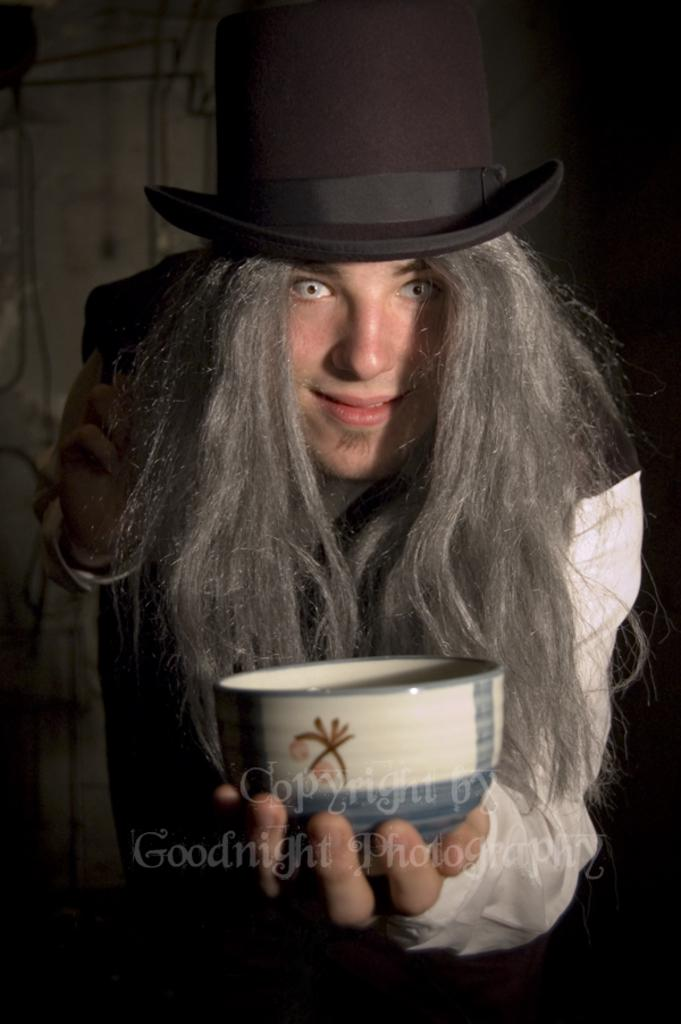What is the main subject of the image? There is a person in the image. What is the person wearing? The person is wearing a hat. What is the person holding? The person is holding a bowl. How would you describe the background of the image? The background of the image is dark. What stage of the key-making process is depicted in the image? There is no key or key-making process present in the image. What type of stage is the person standing on in the image? There is no stage present in the image; the person is holding a bowl and standing in a location with a dark background. 